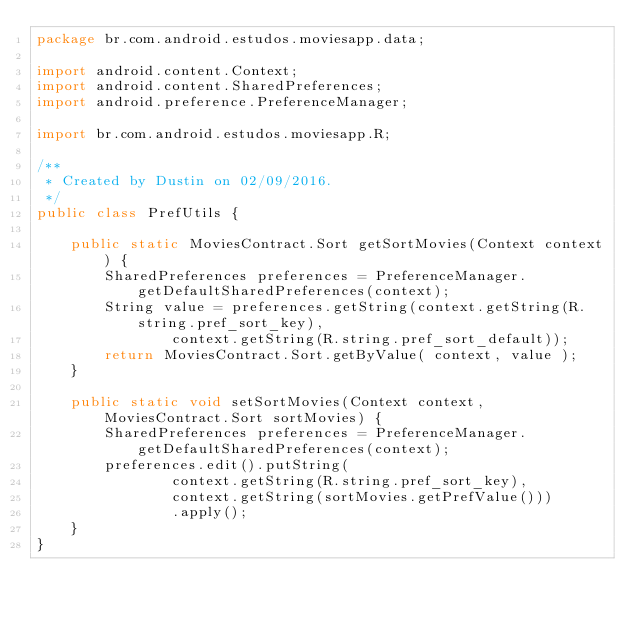Convert code to text. <code><loc_0><loc_0><loc_500><loc_500><_Java_>package br.com.android.estudos.moviesapp.data;

import android.content.Context;
import android.content.SharedPreferences;
import android.preference.PreferenceManager;

import br.com.android.estudos.moviesapp.R;

/**
 * Created by Dustin on 02/09/2016.
 */
public class PrefUtils {

    public static MoviesContract.Sort getSortMovies(Context context) {
        SharedPreferences preferences = PreferenceManager.getDefaultSharedPreferences(context);
        String value = preferences.getString(context.getString(R.string.pref_sort_key),
                context.getString(R.string.pref_sort_default));
        return MoviesContract.Sort.getByValue( context, value );
    }

    public static void setSortMovies(Context context, MoviesContract.Sort sortMovies) {
        SharedPreferences preferences = PreferenceManager.getDefaultSharedPreferences(context);
        preferences.edit().putString(
                context.getString(R.string.pref_sort_key),
                context.getString(sortMovies.getPrefValue()))
                .apply();
    }
}
</code> 